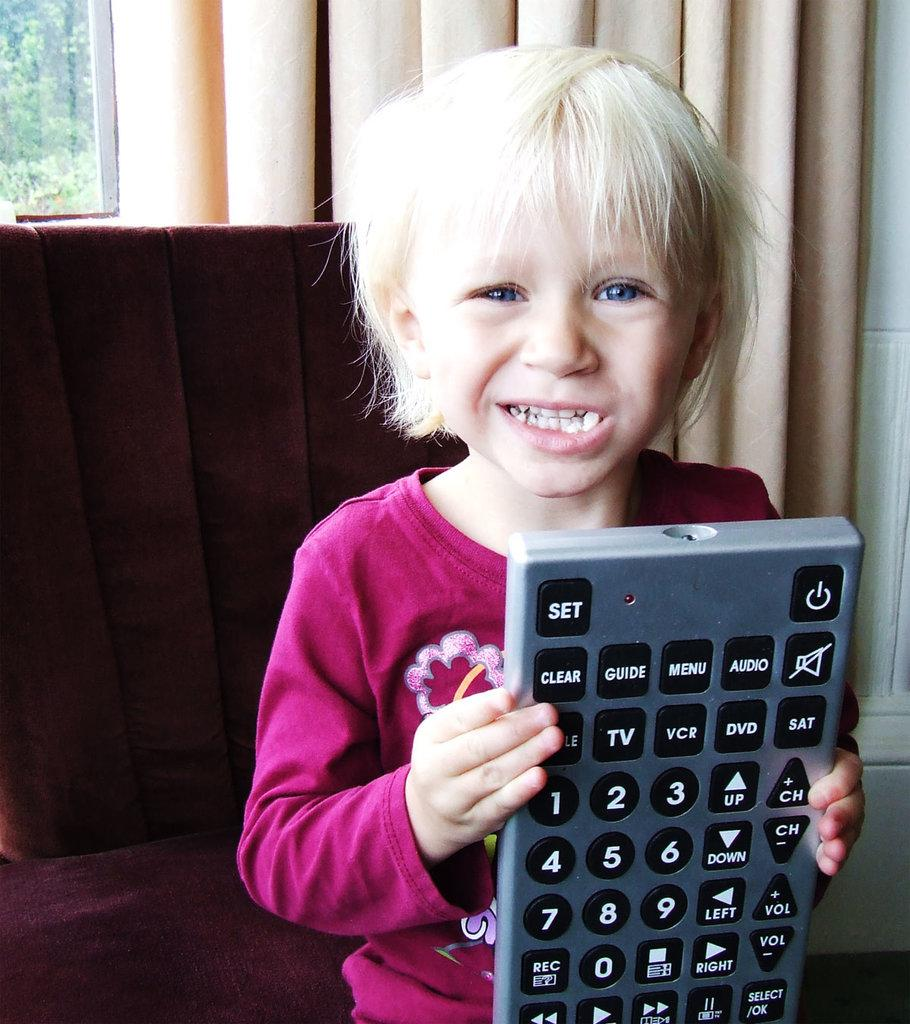<image>
Present a compact description of the photo's key features. A young child smiling and holding a very large remote with buttons like Set, Clear, Guide, Menu, and Audio on it, 